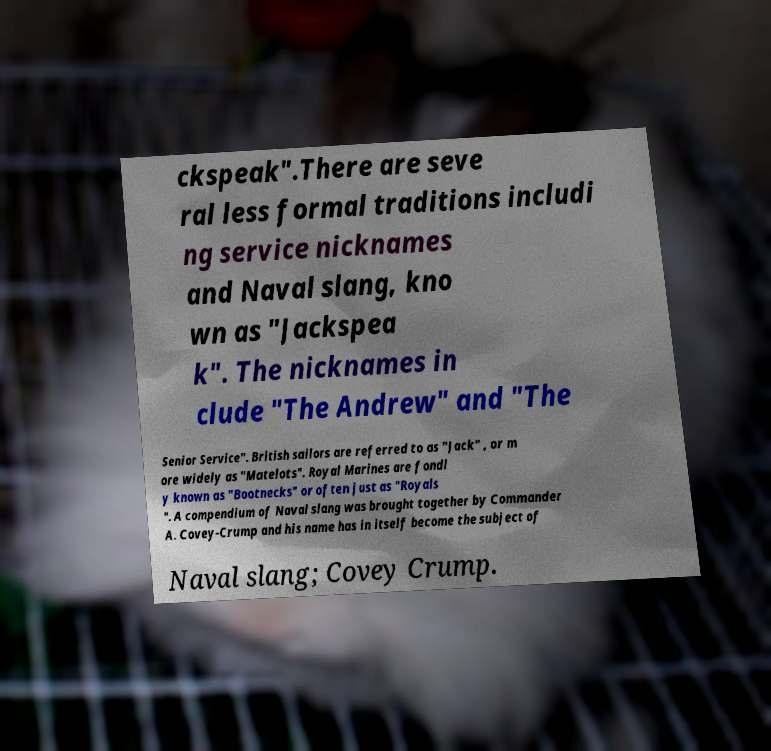Please identify and transcribe the text found in this image. ckspeak".There are seve ral less formal traditions includi ng service nicknames and Naval slang, kno wn as "Jackspea k". The nicknames in clude "The Andrew" and "The Senior Service". British sailors are referred to as "Jack" , or m ore widely as "Matelots". Royal Marines are fondl y known as "Bootnecks" or often just as "Royals ". A compendium of Naval slang was brought together by Commander A. Covey-Crump and his name has in itself become the subject of Naval slang; Covey Crump. 